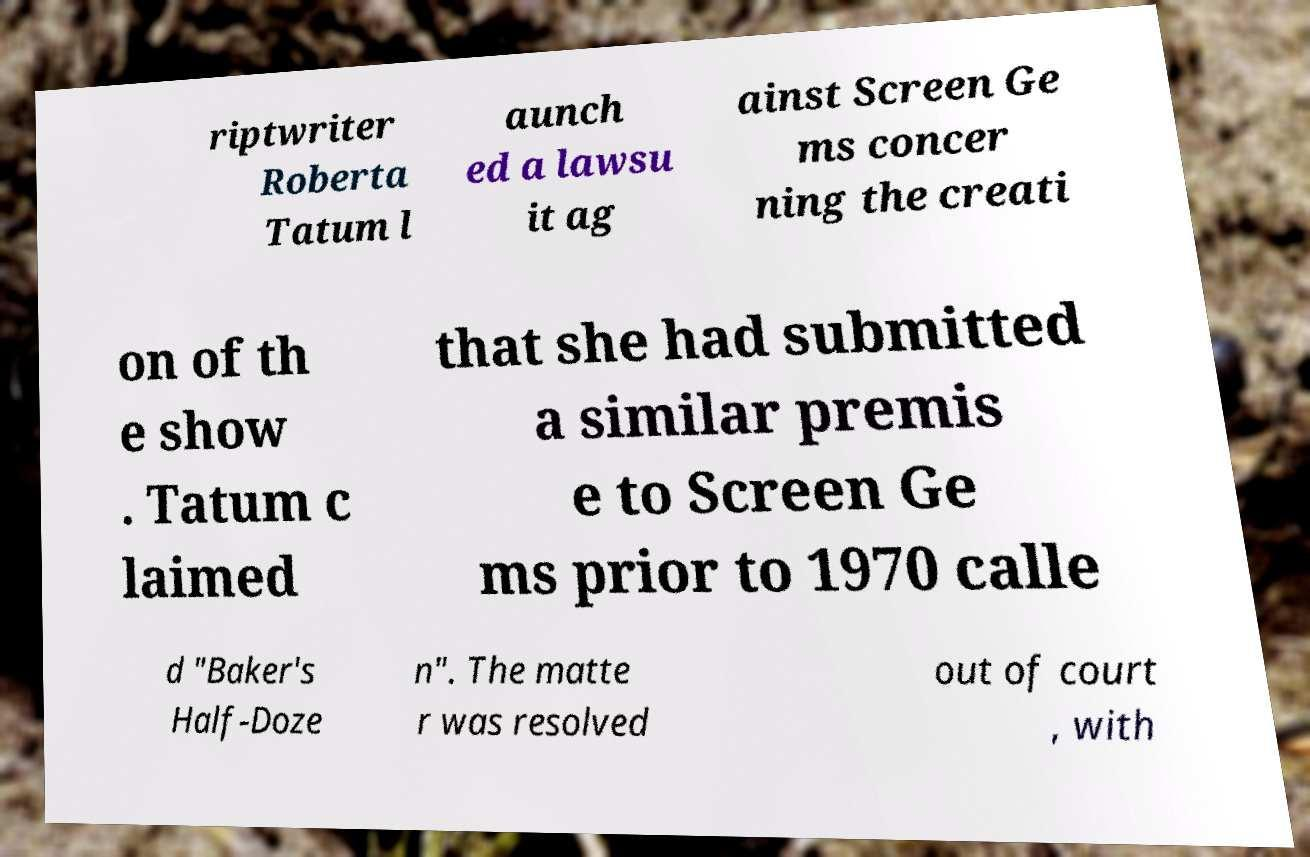Could you extract and type out the text from this image? riptwriter Roberta Tatum l aunch ed a lawsu it ag ainst Screen Ge ms concer ning the creati on of th e show . Tatum c laimed that she had submitted a similar premis e to Screen Ge ms prior to 1970 calle d "Baker's Half-Doze n". The matte r was resolved out of court , with 